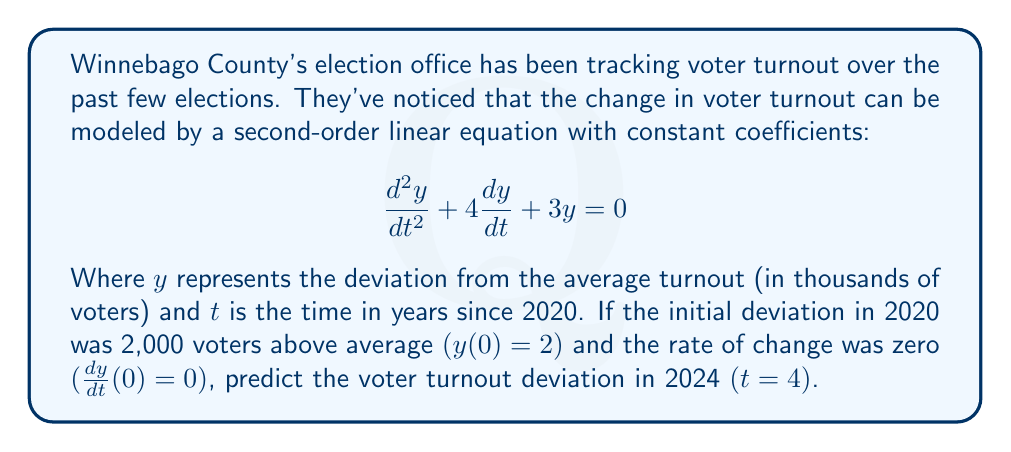Solve this math problem. To solve this problem, we need to follow these steps:

1) The characteristic equation for this second-order linear equation is:
   $$r^2 + 4r + 3 = 0$$

2) Solving this equation:
   $$(r + 1)(r + 3) = 0$$
   $$r = -1 \text{ or } r = -3$$

3) The general solution is therefore:
   $$y = c_1e^{-t} + c_2e^{-3t}$$

4) We need to use the initial conditions to find $c_1$ and $c_2$:
   
   At $t = 0$, $y(0) = 2$:
   $$2 = c_1 + c_2$$

   At $t = 0$, $\frac{dy}{dt}(0) = 0$:
   $$0 = -c_1 - 3c_2$$

5) Solving these simultaneous equations:
   $$c_1 = 3 \text{ and } c_2 = -1$$

6) Therefore, the particular solution is:
   $$y = 3e^{-t} - e^{-3t}$$

7) To find the deviation at $t = 4$:
   $$y(4) = 3e^{-4} - e^{-12}$$

8) Calculating this:
   $$y(4) \approx 0.0547 - 0.0000061 \approx 0.0547$$

This means the deviation in 2024 will be approximately 54.7 voters above the average turnout.
Answer: The voter turnout deviation in Winnebago County in 2024 is predicted to be approximately 54.7 voters above the average turnout. 